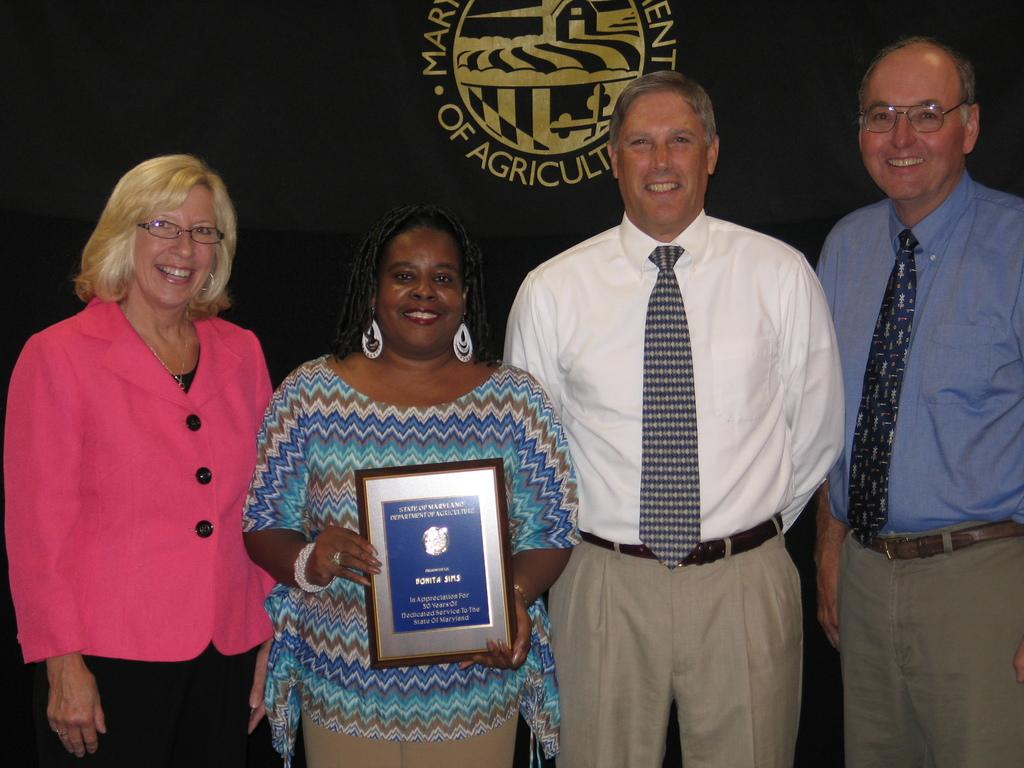How many people are present in the image? There are four people standing in the image. What is the woman holding in the image? The woman is holding a photo frame. What can be seen behind the people in the image? There is a banner visible behind the people. How many tanks are visible in the image? There are no tanks present in the image. What type of clover can be seen growing near the people in the image? There is no clover visible in the image. 